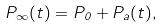<formula> <loc_0><loc_0><loc_500><loc_500>P _ { \infty } ( t ) = P _ { 0 } + P _ { a } ( t ) ,</formula> 